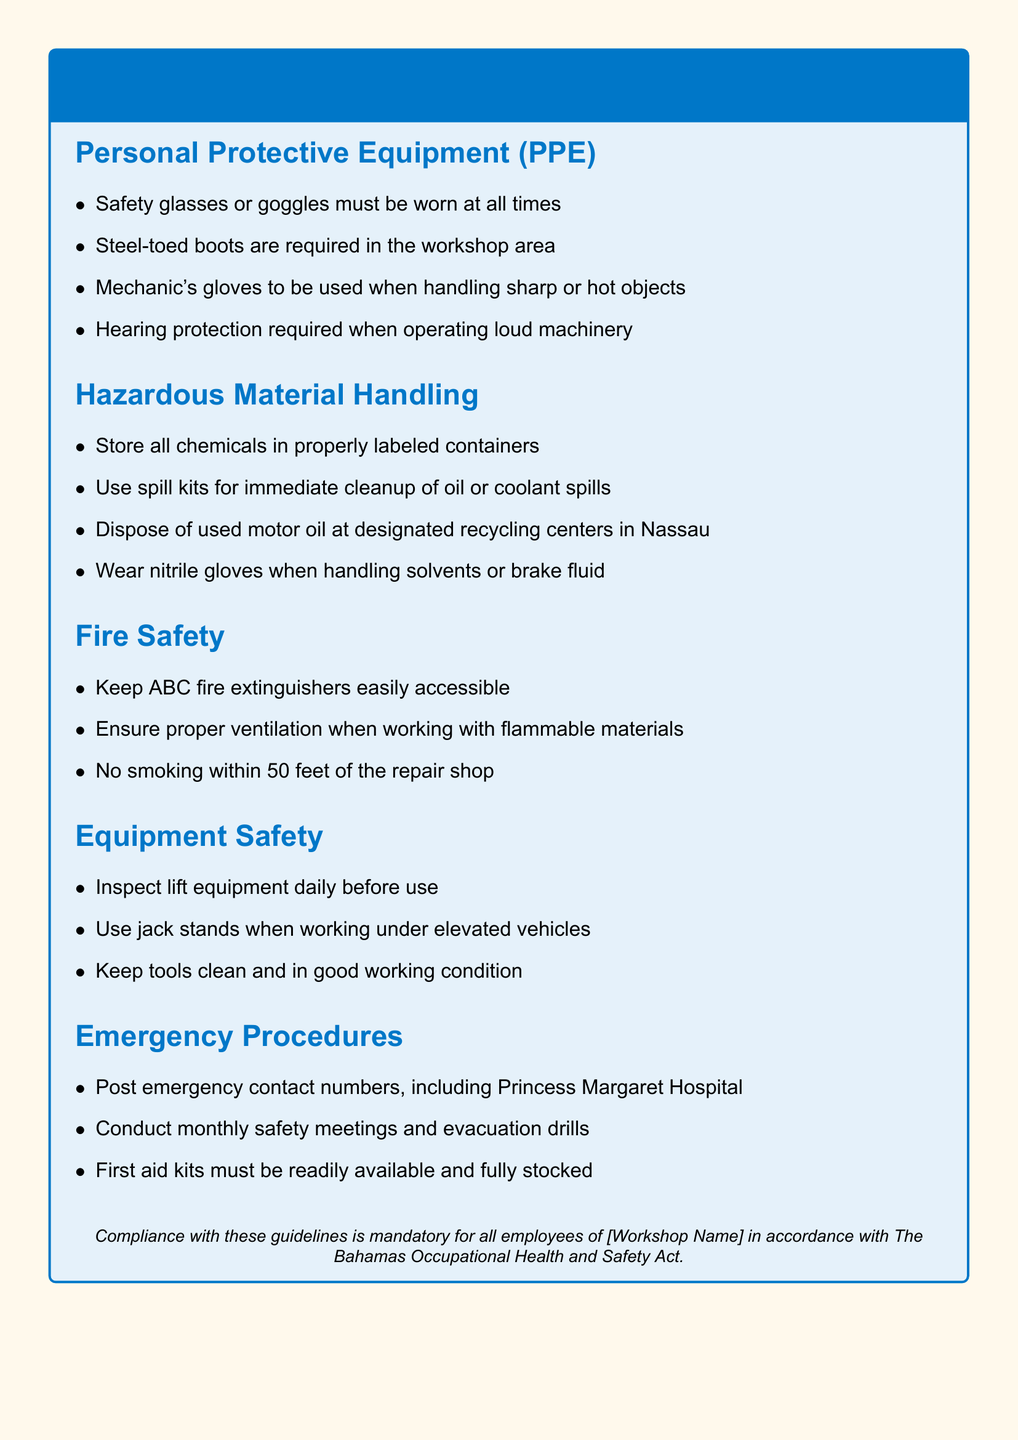What must be worn at all times in the workshop? The guideline specifies that safety glasses or goggles must be worn at all times in the workshop area.
Answer: Safety glasses or goggles What type of boots are required in the workshop area? The document states that steel-toed boots are required in the workshop area for protection.
Answer: Steel-toed boots What should be used for immediate cleanup of oil spills? The guidelines recommend using spill kits for immediate cleanup of oil or coolant spills.
Answer: Spill kits How often should safety meetings be conducted? The document specifies that safety meetings should be conducted monthly to maintain safety awareness.
Answer: Monthly What is the distance for no smoking near the repair shop? The guideline indicates that no smoking is allowed within 50 feet of the repair shop area to prevent fire hazards.
Answer: 50 feet What type of gloves should be worn when handling solvents? The document states that nitrile gloves should be used when handling solvents or brake fluid for protection.
Answer: Nitrile gloves What is required when working under elevated vehicles? The guidelines specify that jack stands should be used when working under elevated vehicles for safety.
Answer: Jack stands When must fire extinguishers be accessible? The document states that ABC fire extinguishers must be kept easily accessible at all times in case of emergencies.
Answer: Easily accessible 